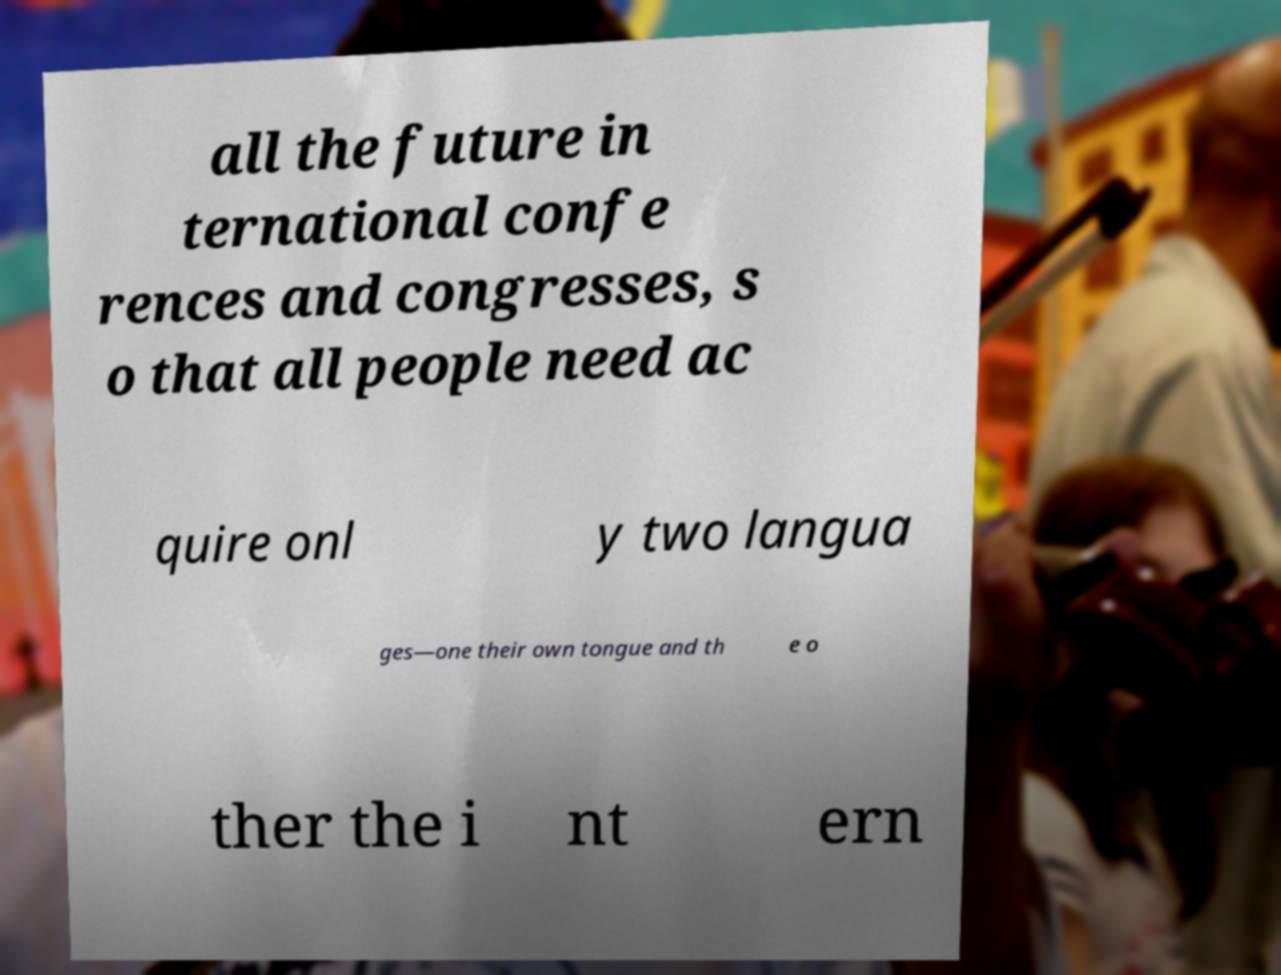What messages or text are displayed in this image? I need them in a readable, typed format. all the future in ternational confe rences and congresses, s o that all people need ac quire onl y two langua ges—one their own tongue and th e o ther the i nt ern 